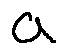<formula> <loc_0><loc_0><loc_500><loc_500>a</formula> 